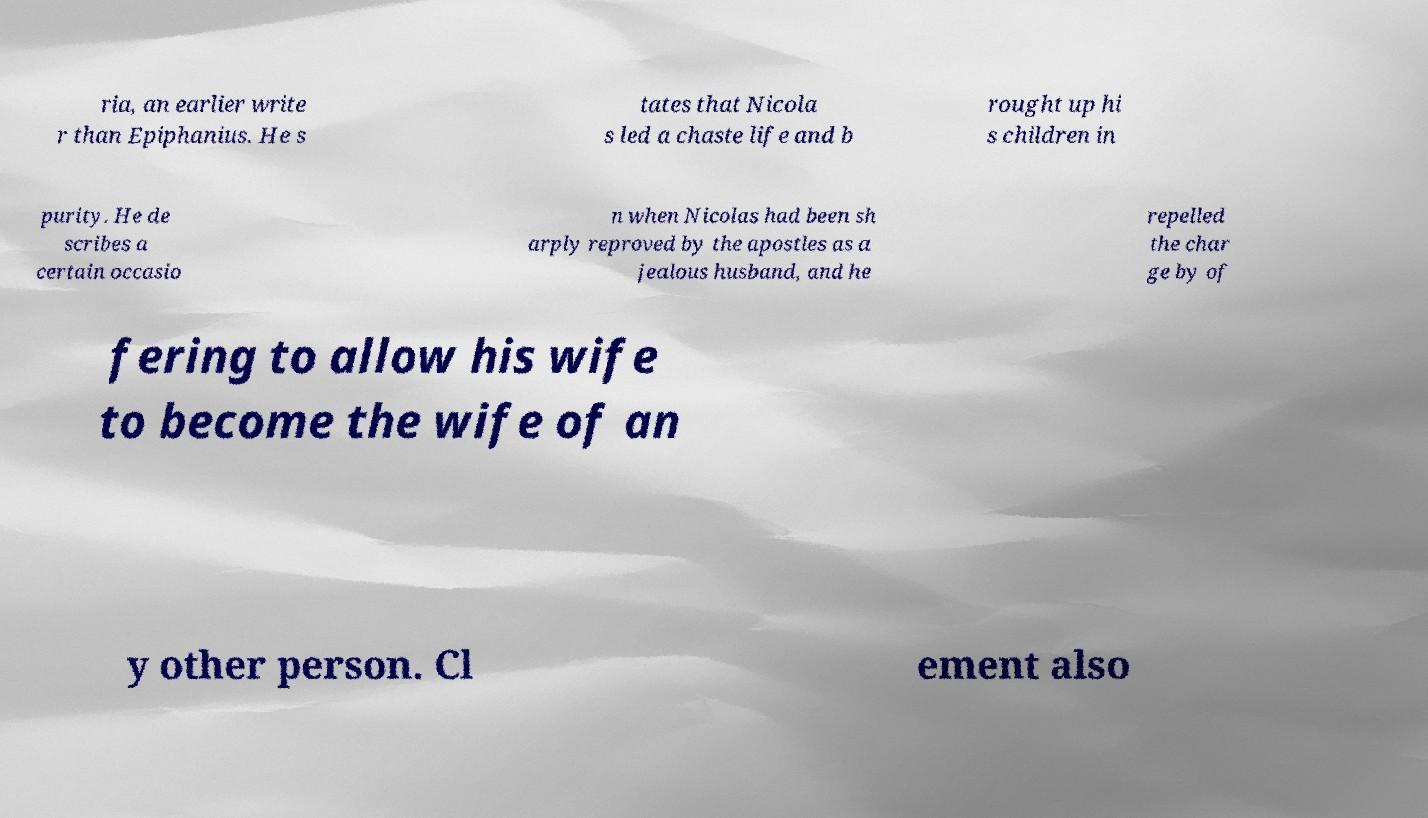I need the written content from this picture converted into text. Can you do that? ria, an earlier write r than Epiphanius. He s tates that Nicola s led a chaste life and b rought up hi s children in purity. He de scribes a certain occasio n when Nicolas had been sh arply reproved by the apostles as a jealous husband, and he repelled the char ge by of fering to allow his wife to become the wife of an y other person. Cl ement also 